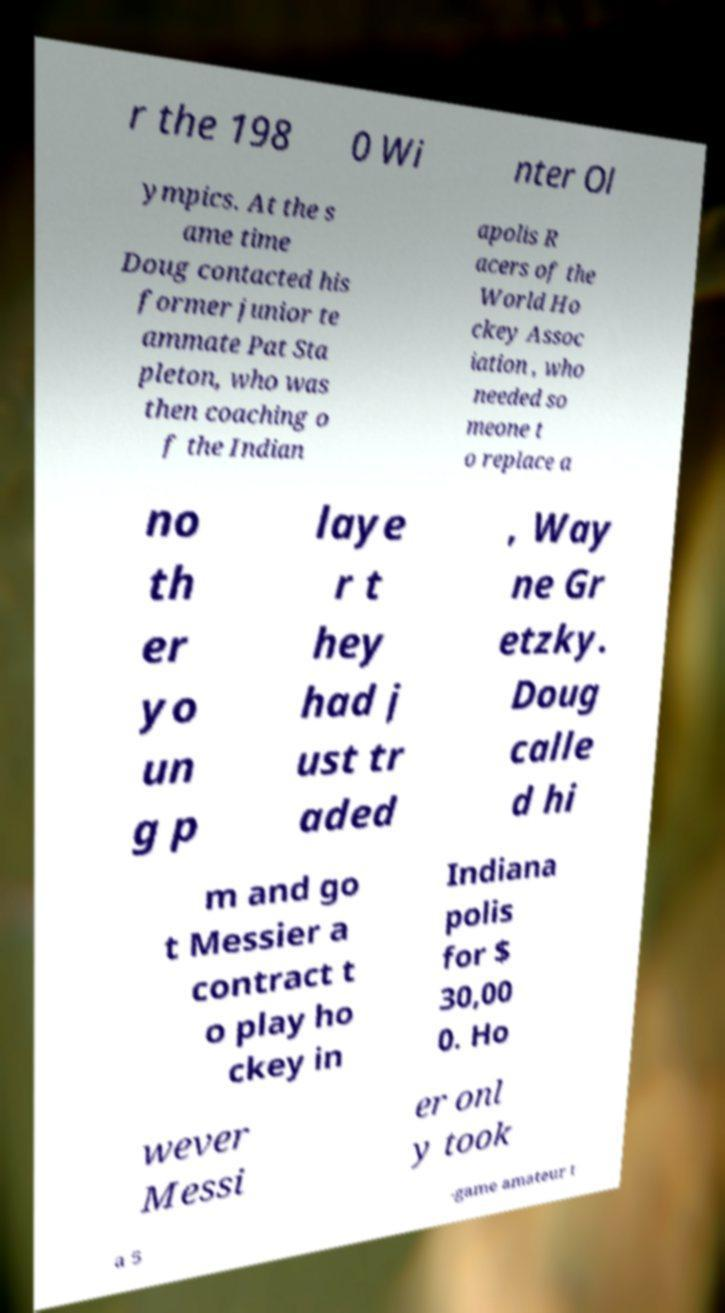Can you read and provide the text displayed in the image?This photo seems to have some interesting text. Can you extract and type it out for me? r the 198 0 Wi nter Ol ympics. At the s ame time Doug contacted his former junior te ammate Pat Sta pleton, who was then coaching o f the Indian apolis R acers of the World Ho ckey Assoc iation , who needed so meone t o replace a no th er yo un g p laye r t hey had j ust tr aded , Way ne Gr etzky. Doug calle d hi m and go t Messier a contract t o play ho ckey in Indiana polis for $ 30,00 0. Ho wever Messi er onl y took a 5 -game amateur t 